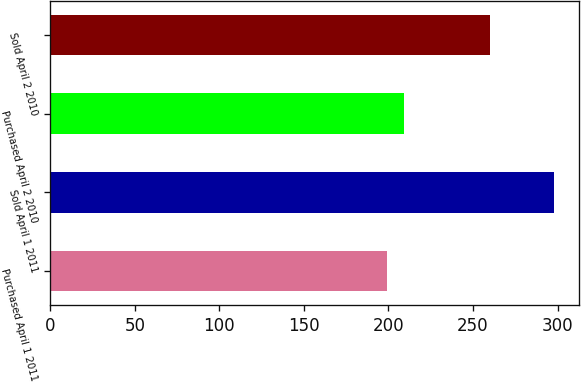Convert chart to OTSL. <chart><loc_0><loc_0><loc_500><loc_500><bar_chart><fcel>Purchased April 1 2011<fcel>Sold April 1 2011<fcel>Purchased April 2 2010<fcel>Sold April 2 2010<nl><fcel>199<fcel>298<fcel>208.9<fcel>260<nl></chart> 